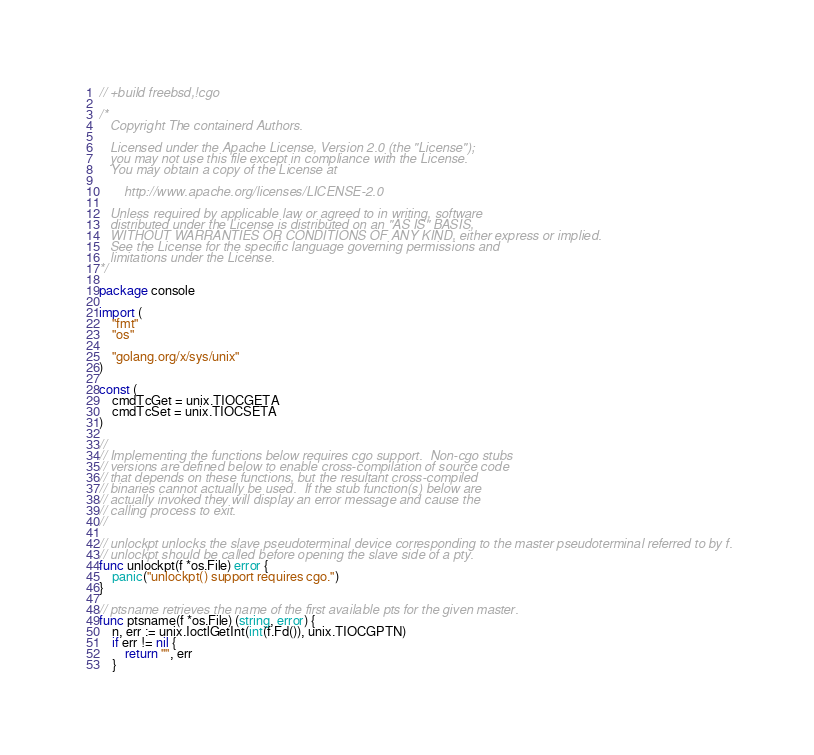Convert code to text. <code><loc_0><loc_0><loc_500><loc_500><_Go_>// +build freebsd,!cgo

/*
   Copyright The containerd Authors.

   Licensed under the Apache License, Version 2.0 (the "License");
   you may not use this file except in compliance with the License.
   You may obtain a copy of the License at

       http://www.apache.org/licenses/LICENSE-2.0

   Unless required by applicable law or agreed to in writing, software
   distributed under the License is distributed on an "AS IS" BASIS,
   WITHOUT WARRANTIES OR CONDITIONS OF ANY KIND, either express or implied.
   See the License for the specific language governing permissions and
   limitations under the License.
*/

package console

import (
	"fmt"
	"os"

	"golang.org/x/sys/unix"
)

const (
	cmdTcGet = unix.TIOCGETA
	cmdTcSet = unix.TIOCSETA
)

//
// Implementing the functions below requires cgo support.  Non-cgo stubs
// versions are defined below to enable cross-compilation of source code
// that depends on these functions, but the resultant cross-compiled
// binaries cannot actually be used.  If the stub function(s) below are
// actually invoked they will display an error message and cause the
// calling process to exit.
//

// unlockpt unlocks the slave pseudoterminal device corresponding to the master pseudoterminal referred to by f.
// unlockpt should be called before opening the slave side of a pty.
func unlockpt(f *os.File) error {
	panic("unlockpt() support requires cgo.")
}

// ptsname retrieves the name of the first available pts for the given master.
func ptsname(f *os.File) (string, error) {
	n, err := unix.IoctlGetInt(int(f.Fd()), unix.TIOCGPTN)
	if err != nil {
		return "", err
	}</code> 